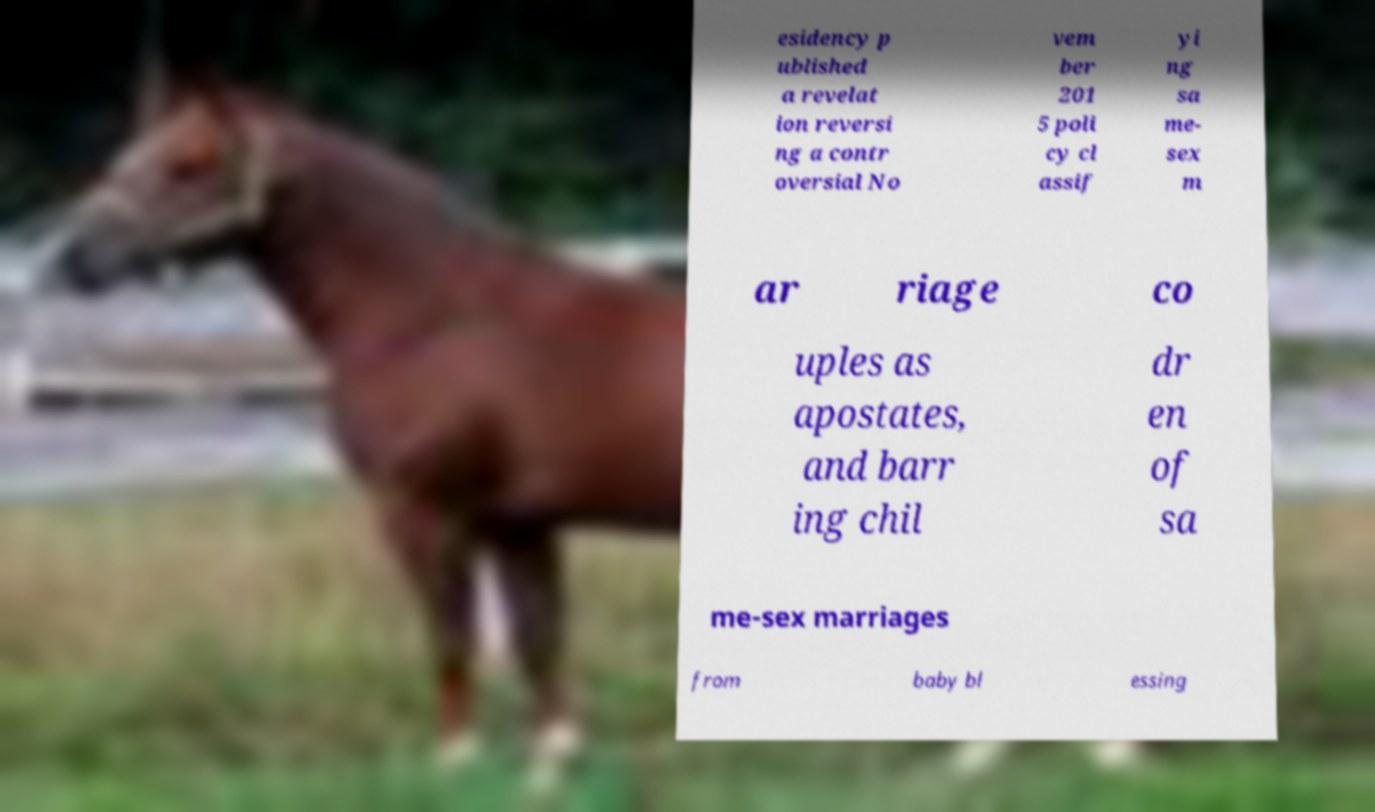There's text embedded in this image that I need extracted. Can you transcribe it verbatim? esidency p ublished a revelat ion reversi ng a contr oversial No vem ber 201 5 poli cy cl assif yi ng sa me- sex m ar riage co uples as apostates, and barr ing chil dr en of sa me-sex marriages from baby bl essing 